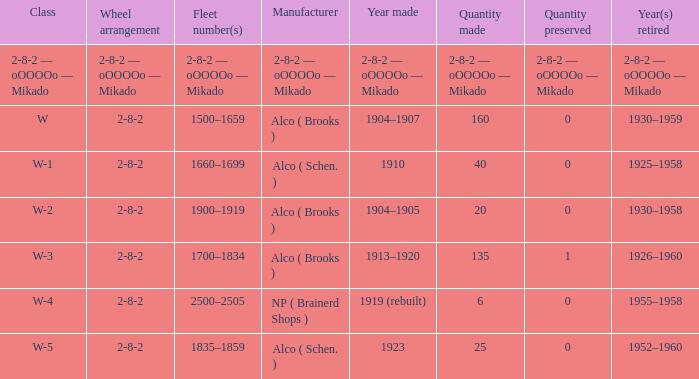What is the locomotive class that has a wheel arrangement of 2-8-2 and a quantity made of 25? W-5. 